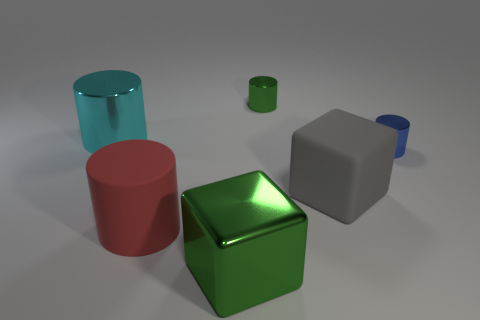What is the color of the thing that is the same material as the gray cube?
Ensure brevity in your answer.  Red. There is a small green object; is it the same shape as the small metal thing in front of the large cyan metallic object?
Provide a short and direct response. Yes. Are there any metallic objects in front of the large cyan metal cylinder?
Your answer should be very brief. Yes. Do the green block and the red cylinder that is in front of the cyan cylinder have the same size?
Your answer should be compact. Yes. Are there any cylinders that have the same color as the big shiny cube?
Ensure brevity in your answer.  Yes. Is there another large object of the same shape as the cyan object?
Ensure brevity in your answer.  Yes. The large object that is on the left side of the large green cube and behind the large red rubber cylinder has what shape?
Keep it short and to the point. Cylinder. How many tiny blue objects have the same material as the green block?
Offer a terse response. 1. Are there fewer red cylinders that are to the right of the tiny green object than gray rubber balls?
Your answer should be very brief. No. There is a green shiny object that is in front of the big red object; are there any things that are right of it?
Provide a short and direct response. Yes. 